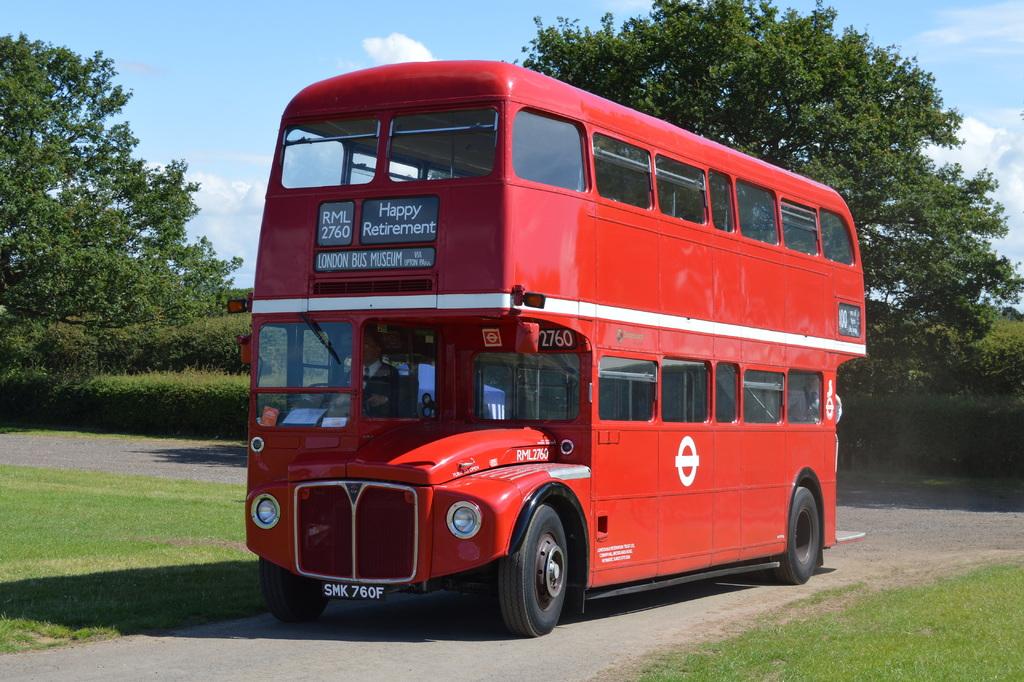Where does this bus stop?
Your answer should be very brief. Unanswerable. What museum name is on the front of the bus?
Provide a short and direct response. London bus museum. 